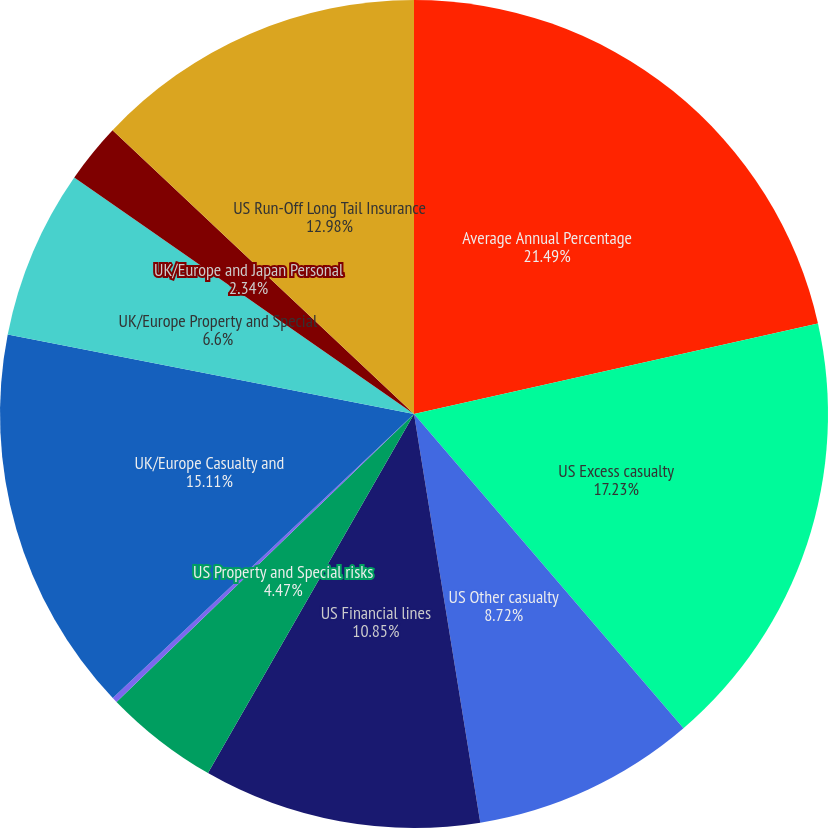Convert chart to OTSL. <chart><loc_0><loc_0><loc_500><loc_500><pie_chart><fcel>Average Annual Percentage<fcel>US Excess casualty<fcel>US Other casualty<fcel>US Financial lines<fcel>US Property and Special risks<fcel>US Personal Insurance<fcel>UK/Europe Casualty and<fcel>UK/Europe Property and Special<fcel>UK/Europe and Japan Personal<fcel>US Run-Off Long Tail Insurance<nl><fcel>21.49%<fcel>17.23%<fcel>8.72%<fcel>10.85%<fcel>4.47%<fcel>0.21%<fcel>15.11%<fcel>6.6%<fcel>2.34%<fcel>12.98%<nl></chart> 